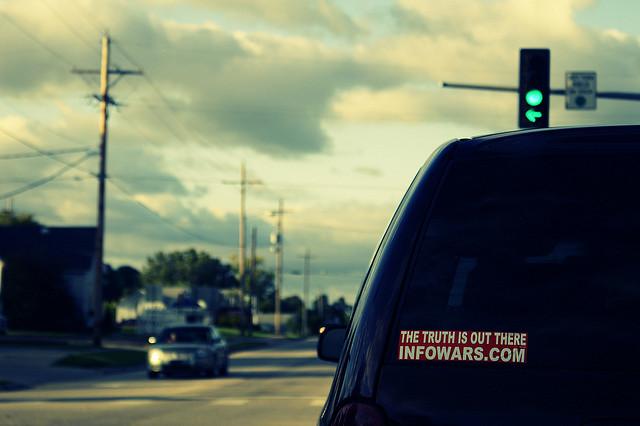What is infowars.com?
Concise answer only. Website. Should the car stop or go now?
Write a very short answer. Go. Should the car in the background on the left stop or go now?
Concise answer only. Stop. 